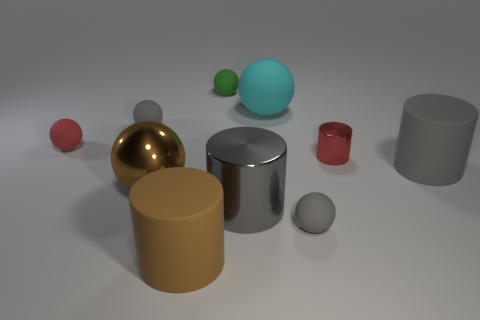Subtract all big cylinders. How many cylinders are left? 1 Subtract all cylinders. How many objects are left? 6 Subtract all gray cylinders. How many cylinders are left? 2 Subtract 0 green cylinders. How many objects are left? 10 Subtract all brown cylinders. Subtract all purple blocks. How many cylinders are left? 3 Subtract all cyan spheres. How many gray cylinders are left? 2 Subtract all gray spheres. Subtract all large shiny objects. How many objects are left? 6 Add 3 red spheres. How many red spheres are left? 4 Add 2 small red cubes. How many small red cubes exist? 2 